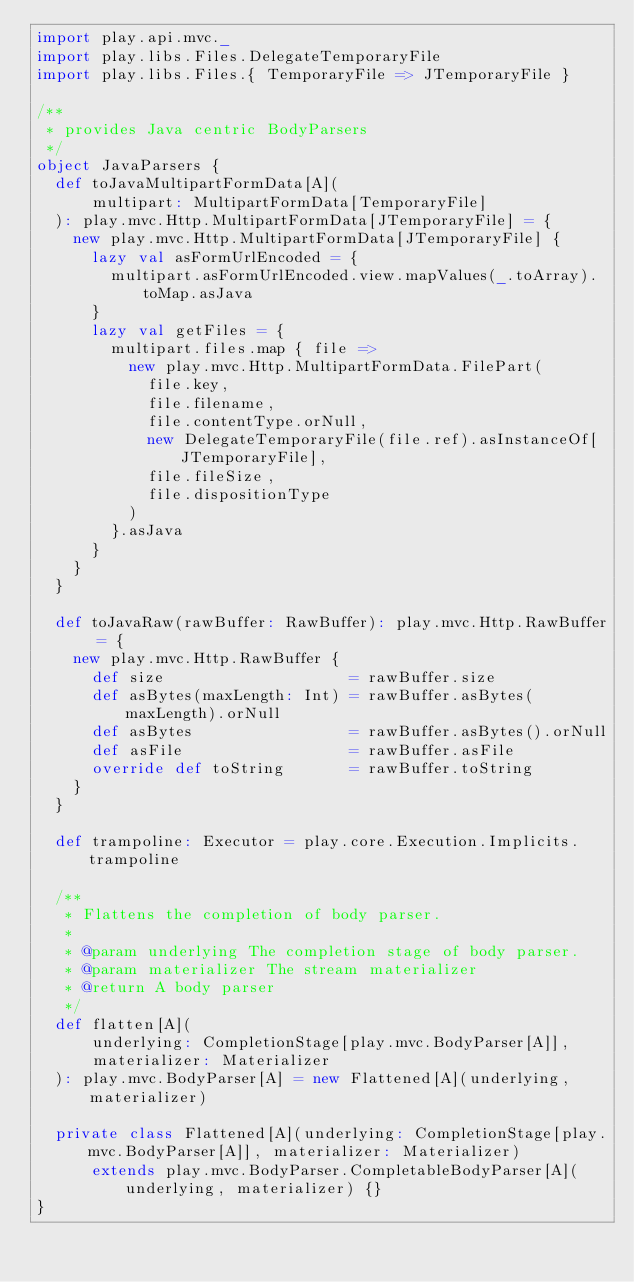<code> <loc_0><loc_0><loc_500><loc_500><_Scala_>import play.api.mvc._
import play.libs.Files.DelegateTemporaryFile
import play.libs.Files.{ TemporaryFile => JTemporaryFile }

/**
 * provides Java centric BodyParsers
 */
object JavaParsers {
  def toJavaMultipartFormData[A](
      multipart: MultipartFormData[TemporaryFile]
  ): play.mvc.Http.MultipartFormData[JTemporaryFile] = {
    new play.mvc.Http.MultipartFormData[JTemporaryFile] {
      lazy val asFormUrlEncoded = {
        multipart.asFormUrlEncoded.view.mapValues(_.toArray).toMap.asJava
      }
      lazy val getFiles = {
        multipart.files.map { file =>
          new play.mvc.Http.MultipartFormData.FilePart(
            file.key,
            file.filename,
            file.contentType.orNull,
            new DelegateTemporaryFile(file.ref).asInstanceOf[JTemporaryFile],
            file.fileSize,
            file.dispositionType
          )
        }.asJava
      }
    }
  }

  def toJavaRaw(rawBuffer: RawBuffer): play.mvc.Http.RawBuffer = {
    new play.mvc.Http.RawBuffer {
      def size                    = rawBuffer.size
      def asBytes(maxLength: Int) = rawBuffer.asBytes(maxLength).orNull
      def asBytes                 = rawBuffer.asBytes().orNull
      def asFile                  = rawBuffer.asFile
      override def toString       = rawBuffer.toString
    }
  }

  def trampoline: Executor = play.core.Execution.Implicits.trampoline

  /**
   * Flattens the completion of body parser.
   *
   * @param underlying The completion stage of body parser.
   * @param materializer The stream materializer
   * @return A body parser
   */
  def flatten[A](
      underlying: CompletionStage[play.mvc.BodyParser[A]],
      materializer: Materializer
  ): play.mvc.BodyParser[A] = new Flattened[A](underlying, materializer)

  private class Flattened[A](underlying: CompletionStage[play.mvc.BodyParser[A]], materializer: Materializer)
      extends play.mvc.BodyParser.CompletableBodyParser[A](underlying, materializer) {}
}
</code> 